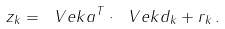<formula> <loc_0><loc_0><loc_500><loc_500>z _ { k } = \ V e k { a } ^ { T } \cdot \ V e k { d } _ { k } + r _ { k } \, .</formula> 